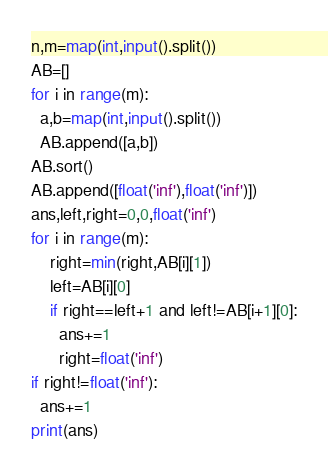Convert code to text. <code><loc_0><loc_0><loc_500><loc_500><_Python_>n,m=map(int,input().split())
AB=[]
for i in range(m):
  a,b=map(int,input().split())
  AB.append([a,b])
AB.sort()
AB.append([float('inf'),float('inf')])
ans,left,right=0,0,float('inf')
for i in range(m):
    right=min(right,AB[i][1])
    left=AB[i][0]
    if right==left+1 and left!=AB[i+1][0]:
      ans+=1
      right=float('inf')
if right!=float('inf'):
  ans+=1
print(ans)
</code> 